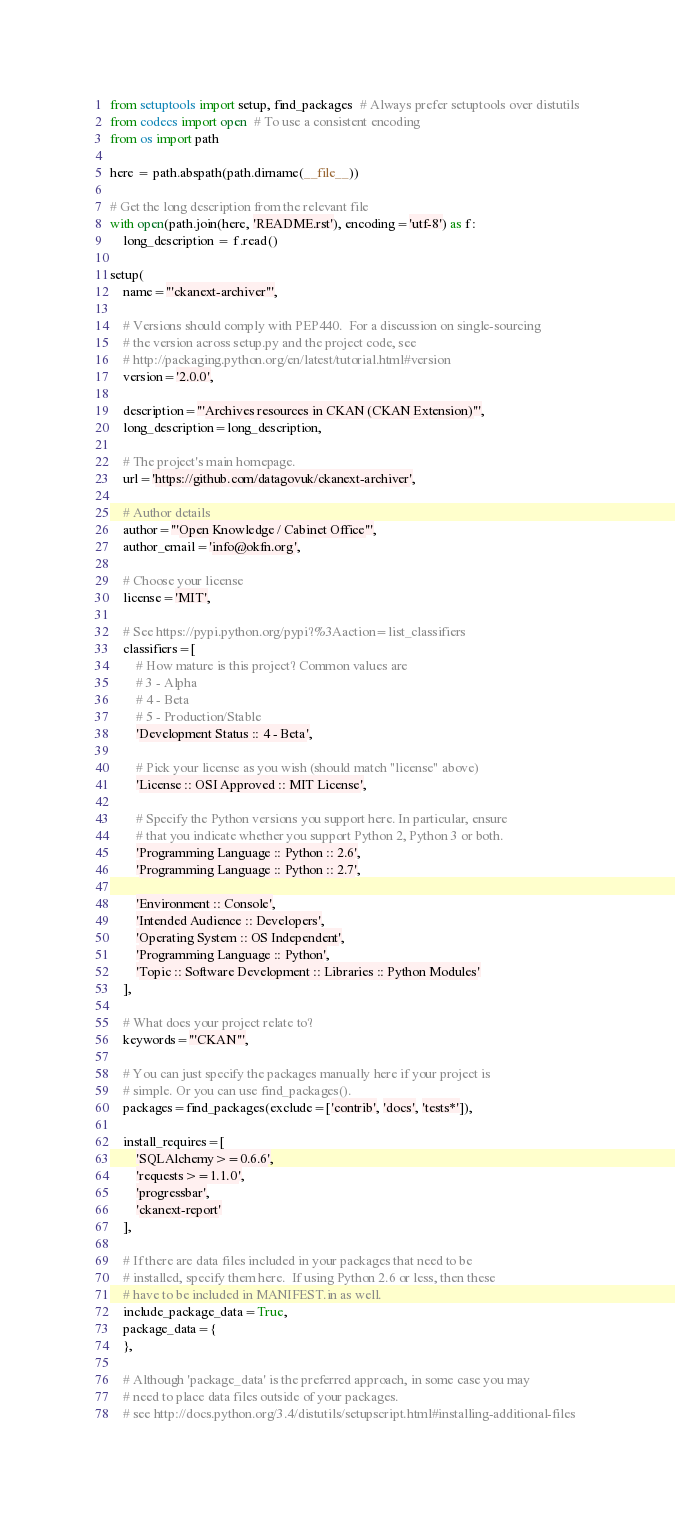Convert code to text. <code><loc_0><loc_0><loc_500><loc_500><_Python_>from setuptools import setup, find_packages  # Always prefer setuptools over distutils
from codecs import open  # To use a consistent encoding
from os import path

here = path.abspath(path.dirname(__file__))

# Get the long description from the relevant file
with open(path.join(here, 'README.rst'), encoding='utf-8') as f:
    long_description = f.read()

setup(
    name='''ckanext-archiver''',

    # Versions should comply with PEP440.  For a discussion on single-sourcing
    # the version across setup.py and the project code, see
    # http://packaging.python.org/en/latest/tutorial.html#version
    version='2.0.0',

    description='''Archives resources in CKAN (CKAN Extension)''',
    long_description=long_description,

    # The project's main homepage.
    url='https://github.com/datagovuk/ckanext-archiver',

    # Author details
    author='''Open Knowledge / Cabinet Office''',
    author_email='info@okfn.org',

    # Choose your license
    license='MIT',

    # See https://pypi.python.org/pypi?%3Aaction=list_classifiers
    classifiers=[
        # How mature is this project? Common values are
        # 3 - Alpha
        # 4 - Beta
        # 5 - Production/Stable
        'Development Status :: 4 - Beta',

        # Pick your license as you wish (should match "license" above)
        'License :: OSI Approved :: MIT License',

        # Specify the Python versions you support here. In particular, ensure
        # that you indicate whether you support Python 2, Python 3 or both.
        'Programming Language :: Python :: 2.6',
        'Programming Language :: Python :: 2.7',

        'Environment :: Console',
        'Intended Audience :: Developers',
        'Operating System :: OS Independent',
        'Programming Language :: Python',
        'Topic :: Software Development :: Libraries :: Python Modules'
    ],

    # What does your project relate to?
    keywords='''CKAN''',

    # You can just specify the packages manually here if your project is
    # simple. Or you can use find_packages().
    packages=find_packages(exclude=['contrib', 'docs', 'tests*']),

    install_requires=[
        'SQLAlchemy>=0.6.6',
        'requests>=1.1.0',
        'progressbar',
        'ckanext-report'
    ],

    # If there are data files included in your packages that need to be
    # installed, specify them here.  If using Python 2.6 or less, then these
    # have to be included in MANIFEST.in as well.
    include_package_data=True,
    package_data={
    },

    # Although 'package_data' is the preferred approach, in some case you may
    # need to place data files outside of your packages.
    # see http://docs.python.org/3.4/distutils/setupscript.html#installing-additional-files</code> 